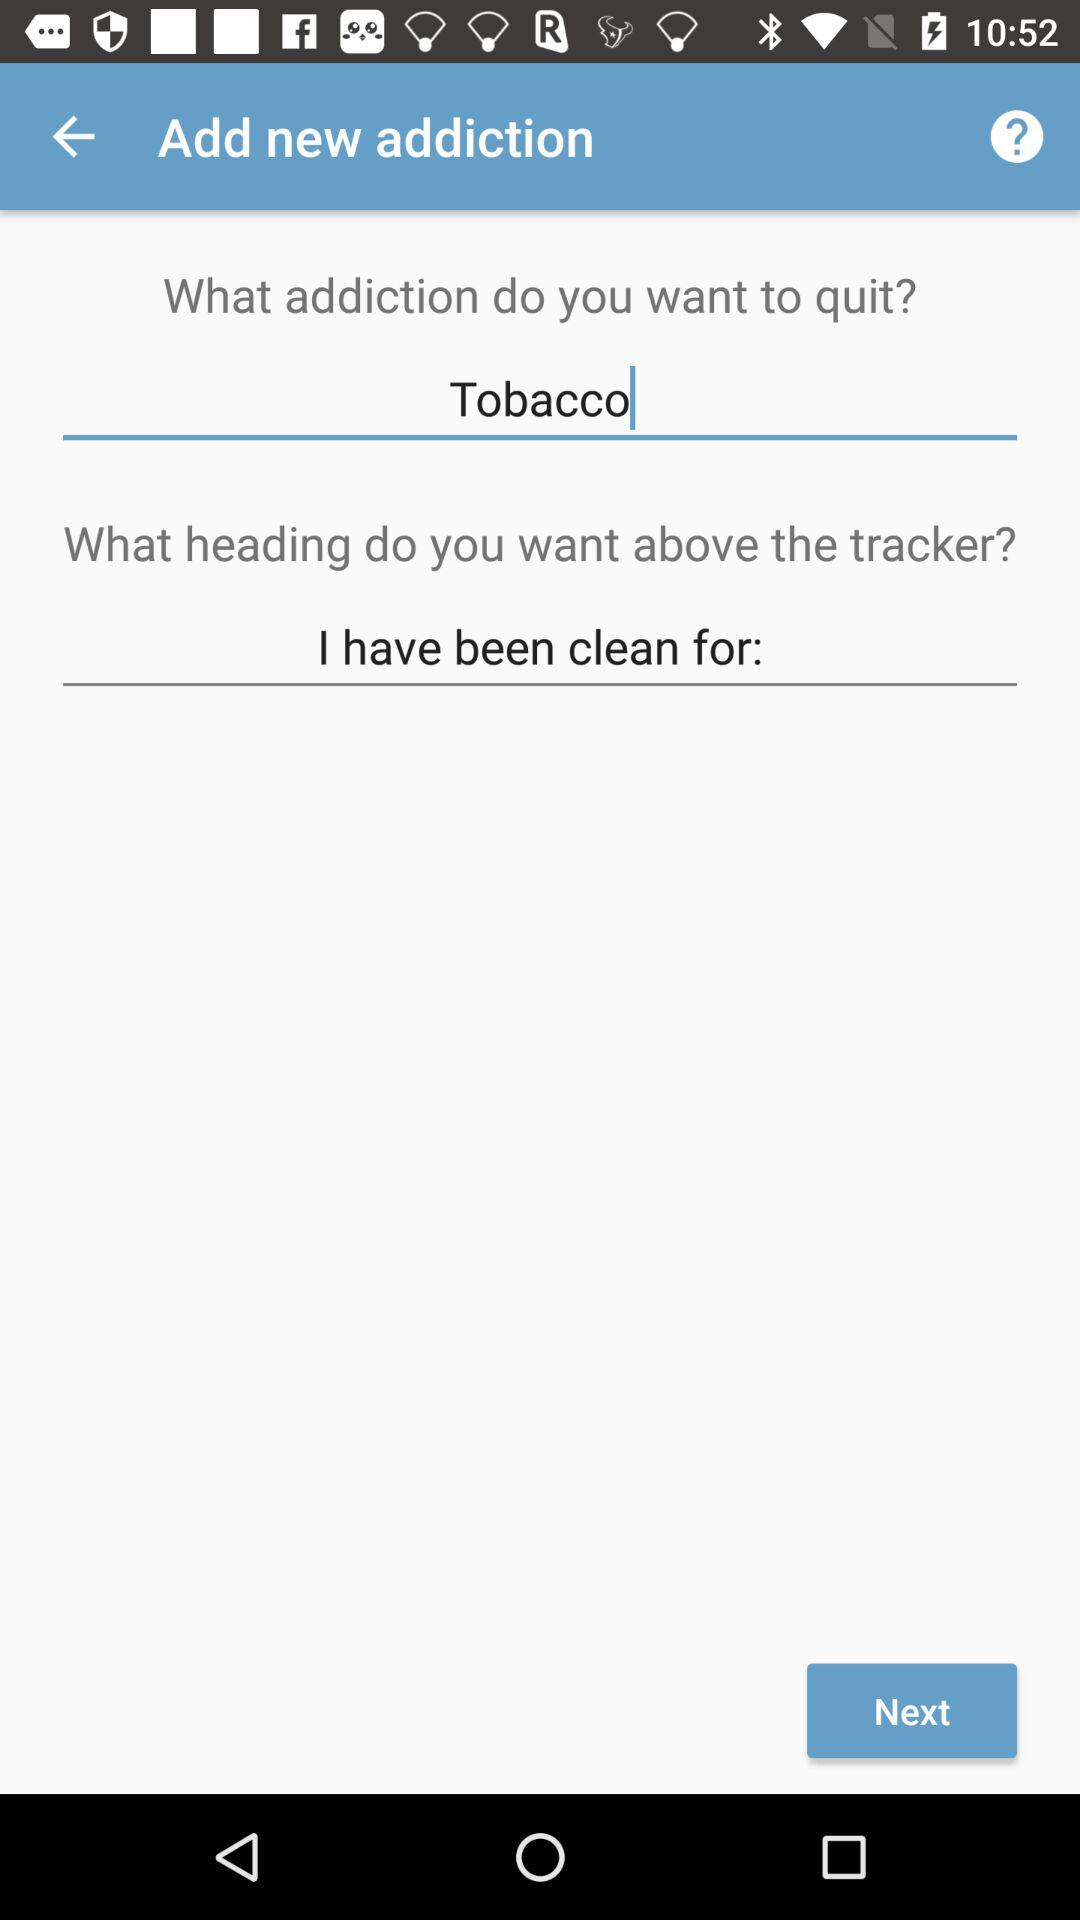Which question has the answer "I have been clean for:"? The question is "What heading do you want above the tracker?". 